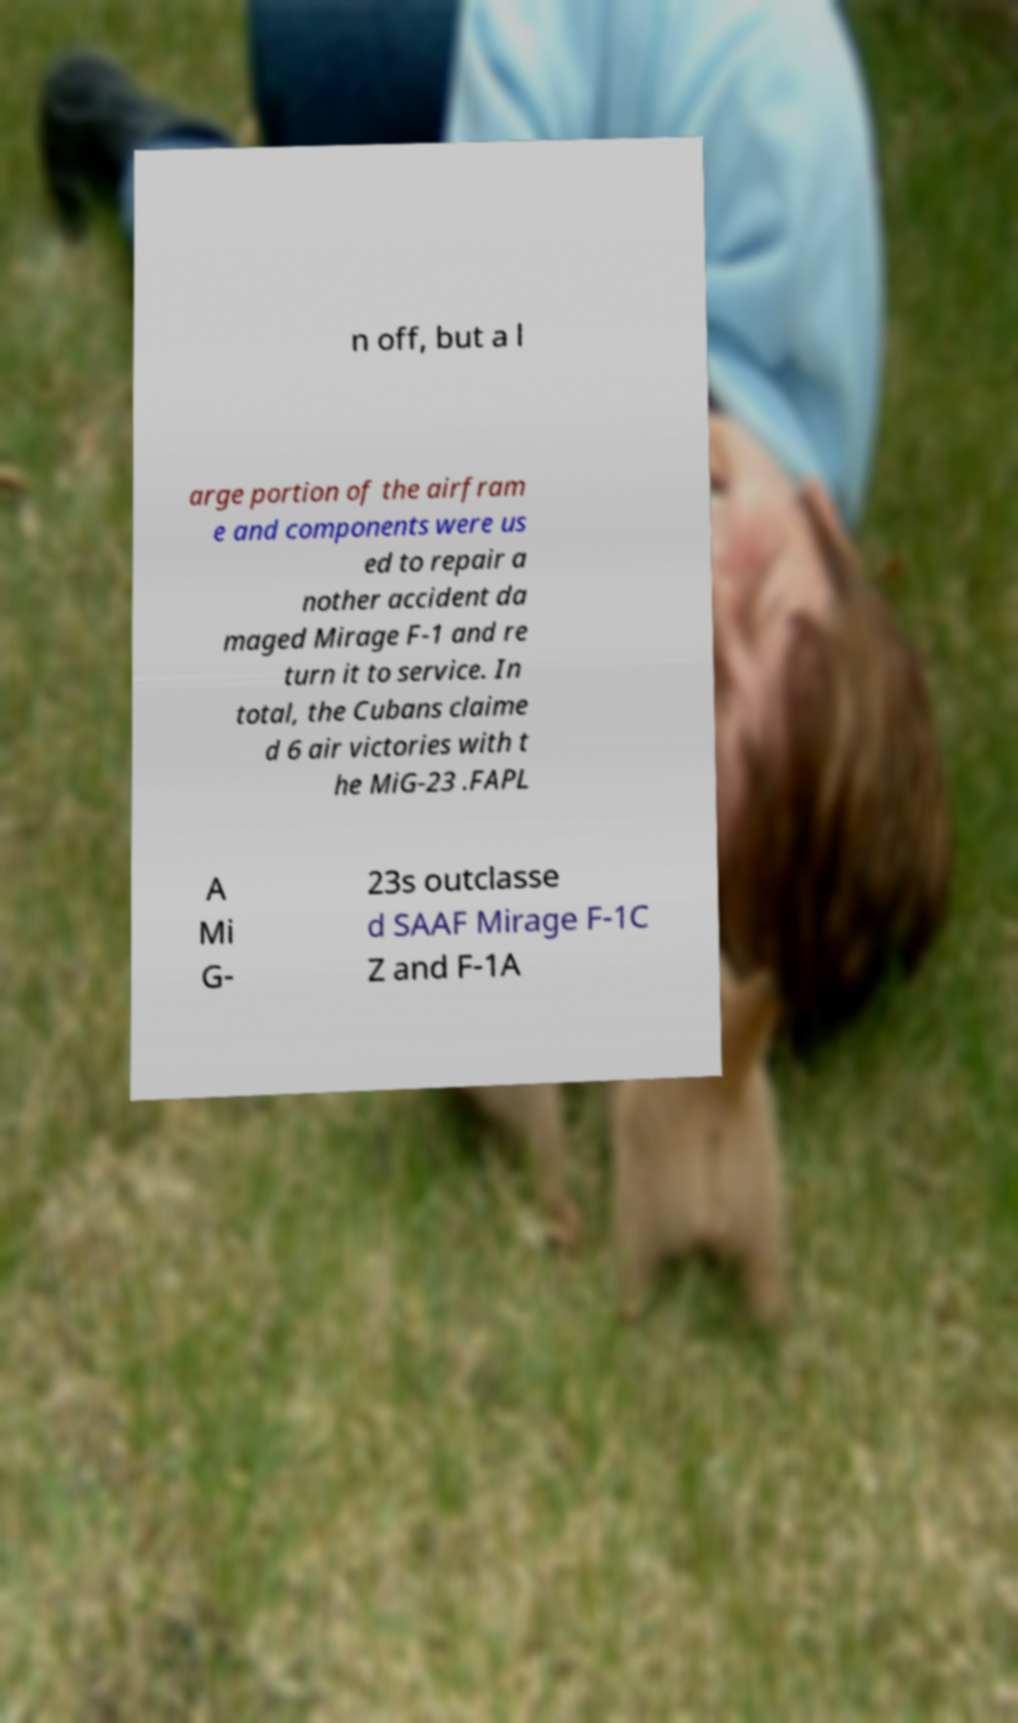Could you assist in decoding the text presented in this image and type it out clearly? n off, but a l arge portion of the airfram e and components were us ed to repair a nother accident da maged Mirage F-1 and re turn it to service. In total, the Cubans claime d 6 air victories with t he MiG-23 .FAPL A Mi G- 23s outclasse d SAAF Mirage F-1C Z and F-1A 